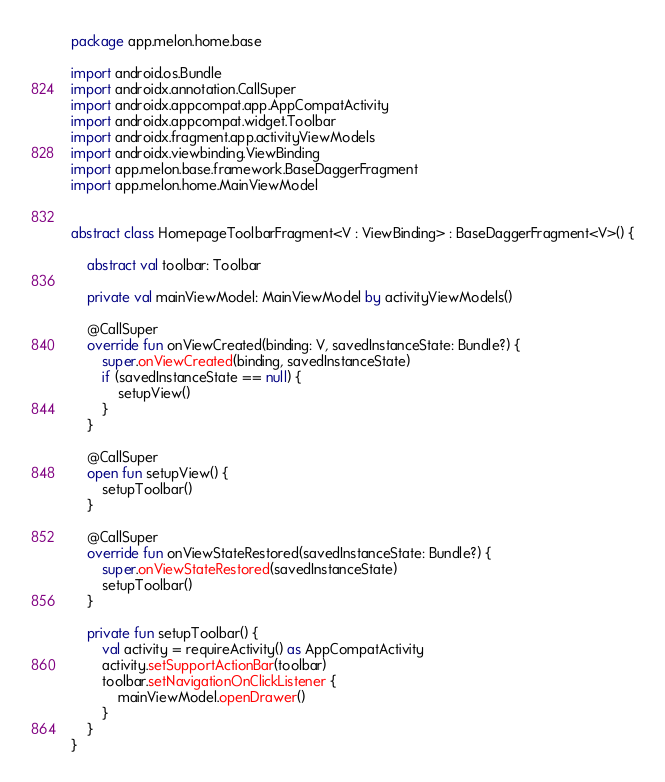Convert code to text. <code><loc_0><loc_0><loc_500><loc_500><_Kotlin_>package app.melon.home.base

import android.os.Bundle
import androidx.annotation.CallSuper
import androidx.appcompat.app.AppCompatActivity
import androidx.appcompat.widget.Toolbar
import androidx.fragment.app.activityViewModels
import androidx.viewbinding.ViewBinding
import app.melon.base.framework.BaseDaggerFragment
import app.melon.home.MainViewModel


abstract class HomepageToolbarFragment<V : ViewBinding> : BaseDaggerFragment<V>() {

    abstract val toolbar: Toolbar

    private val mainViewModel: MainViewModel by activityViewModels()

    @CallSuper
    override fun onViewCreated(binding: V, savedInstanceState: Bundle?) {
        super.onViewCreated(binding, savedInstanceState)
        if (savedInstanceState == null) {
            setupView()
        }
    }

    @CallSuper
    open fun setupView() {
        setupToolbar()
    }

    @CallSuper
    override fun onViewStateRestored(savedInstanceState: Bundle?) {
        super.onViewStateRestored(savedInstanceState)
        setupToolbar()
    }

    private fun setupToolbar() {
        val activity = requireActivity() as AppCompatActivity
        activity.setSupportActionBar(toolbar)
        toolbar.setNavigationOnClickListener {
            mainViewModel.openDrawer()
        }
    }
}</code> 